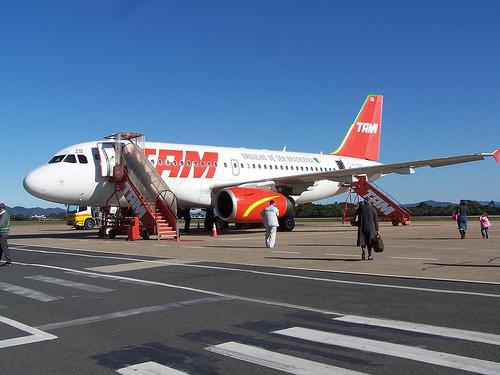Question: where are windows?
Choices:
A. On the bus.
B. On the plane.
C. On the train.
D. On the car.
Answer with the letter. Answer: B Question: what is gray?
Choices:
A. Ground.
B. Pavement.
C. Street.
D. Trucks.
Answer with the letter. Answer: A Question: what is white and red?
Choices:
A. A car.
B. A truck.
C. Plane.
D. A wagon.
Answer with the letter. Answer: C Question: why does a plane have wings?
Choices:
A. To keep it in the air.
B. To fly.
C. To balance the plane.
D. To keep air flow good.
Answer with the letter. Answer: B Question: where are white lines?
Choices:
A. On the road.
B. In the parking lot.
C. On the ground.
D. On the tennis court.
Answer with the letter. Answer: C Question: where was the photo taken?
Choices:
A. The river.
B. The  woods.
C. The beach.
D. Near plane.
Answer with the letter. Answer: D 